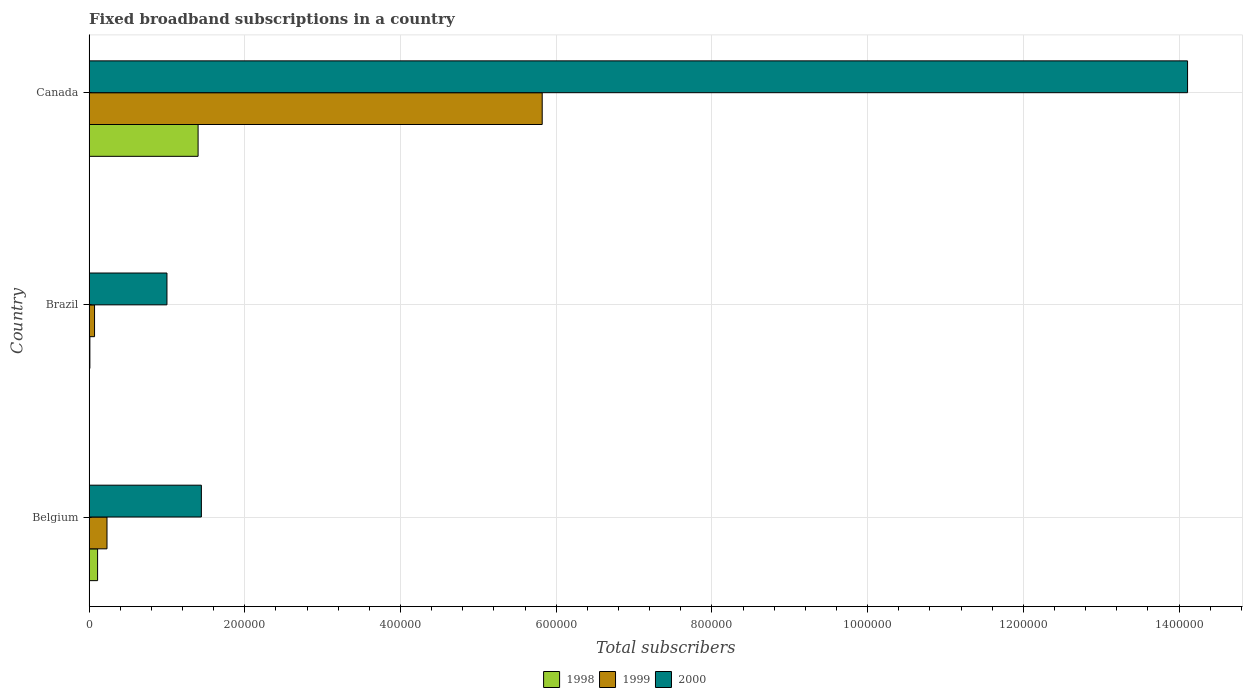How many different coloured bars are there?
Provide a short and direct response. 3. How many groups of bars are there?
Make the answer very short. 3. Are the number of bars per tick equal to the number of legend labels?
Your response must be concise. Yes. How many bars are there on the 3rd tick from the top?
Your answer should be compact. 3. What is the label of the 1st group of bars from the top?
Offer a terse response. Canada. What is the number of broadband subscriptions in 1999 in Belgium?
Keep it short and to the point. 2.30e+04. Across all countries, what is the maximum number of broadband subscriptions in 1999?
Your response must be concise. 5.82e+05. In which country was the number of broadband subscriptions in 2000 minimum?
Provide a succinct answer. Brazil. What is the total number of broadband subscriptions in 2000 in the graph?
Offer a very short reply. 1.66e+06. What is the difference between the number of broadband subscriptions in 2000 in Belgium and that in Brazil?
Offer a very short reply. 4.42e+04. What is the difference between the number of broadband subscriptions in 1999 in Canada and the number of broadband subscriptions in 2000 in Brazil?
Ensure brevity in your answer.  4.82e+05. What is the average number of broadband subscriptions in 2000 per country?
Provide a succinct answer. 5.52e+05. What is the difference between the number of broadband subscriptions in 2000 and number of broadband subscriptions in 1998 in Canada?
Your response must be concise. 1.27e+06. In how many countries, is the number of broadband subscriptions in 1999 greater than 960000 ?
Give a very brief answer. 0. What is the ratio of the number of broadband subscriptions in 1999 in Brazil to that in Canada?
Your answer should be very brief. 0.01. Is the number of broadband subscriptions in 1998 in Belgium less than that in Brazil?
Offer a very short reply. No. Is the difference between the number of broadband subscriptions in 2000 in Brazil and Canada greater than the difference between the number of broadband subscriptions in 1998 in Brazil and Canada?
Make the answer very short. No. What is the difference between the highest and the second highest number of broadband subscriptions in 1998?
Your response must be concise. 1.29e+05. What is the difference between the highest and the lowest number of broadband subscriptions in 1998?
Offer a very short reply. 1.39e+05. Is it the case that in every country, the sum of the number of broadband subscriptions in 1999 and number of broadband subscriptions in 1998 is greater than the number of broadband subscriptions in 2000?
Give a very brief answer. No. What is the difference between two consecutive major ticks on the X-axis?
Give a very brief answer. 2.00e+05. Does the graph contain any zero values?
Ensure brevity in your answer.  No. Does the graph contain grids?
Your answer should be very brief. Yes. Where does the legend appear in the graph?
Keep it short and to the point. Bottom center. How are the legend labels stacked?
Provide a succinct answer. Horizontal. What is the title of the graph?
Provide a succinct answer. Fixed broadband subscriptions in a country. What is the label or title of the X-axis?
Your answer should be very brief. Total subscribers. What is the label or title of the Y-axis?
Ensure brevity in your answer.  Country. What is the Total subscribers in 1998 in Belgium?
Give a very brief answer. 1.09e+04. What is the Total subscribers of 1999 in Belgium?
Your answer should be compact. 2.30e+04. What is the Total subscribers of 2000 in Belgium?
Provide a succinct answer. 1.44e+05. What is the Total subscribers of 1998 in Brazil?
Provide a succinct answer. 1000. What is the Total subscribers in 1999 in Brazil?
Give a very brief answer. 7000. What is the Total subscribers of 2000 in Brazil?
Your answer should be very brief. 1.00e+05. What is the Total subscribers of 1998 in Canada?
Offer a terse response. 1.40e+05. What is the Total subscribers of 1999 in Canada?
Offer a very short reply. 5.82e+05. What is the Total subscribers in 2000 in Canada?
Ensure brevity in your answer.  1.41e+06. Across all countries, what is the maximum Total subscribers in 1999?
Ensure brevity in your answer.  5.82e+05. Across all countries, what is the maximum Total subscribers of 2000?
Provide a succinct answer. 1.41e+06. Across all countries, what is the minimum Total subscribers of 1998?
Offer a terse response. 1000. Across all countries, what is the minimum Total subscribers of 1999?
Offer a terse response. 7000. What is the total Total subscribers of 1998 in the graph?
Your response must be concise. 1.52e+05. What is the total Total subscribers in 1999 in the graph?
Your answer should be very brief. 6.12e+05. What is the total Total subscribers of 2000 in the graph?
Make the answer very short. 1.66e+06. What is the difference between the Total subscribers of 1998 in Belgium and that in Brazil?
Provide a short and direct response. 9924. What is the difference between the Total subscribers in 1999 in Belgium and that in Brazil?
Keep it short and to the point. 1.60e+04. What is the difference between the Total subscribers of 2000 in Belgium and that in Brazil?
Offer a very short reply. 4.42e+04. What is the difference between the Total subscribers in 1998 in Belgium and that in Canada?
Provide a succinct answer. -1.29e+05. What is the difference between the Total subscribers in 1999 in Belgium and that in Canada?
Provide a short and direct response. -5.59e+05. What is the difference between the Total subscribers of 2000 in Belgium and that in Canada?
Provide a short and direct response. -1.27e+06. What is the difference between the Total subscribers in 1998 in Brazil and that in Canada?
Offer a very short reply. -1.39e+05. What is the difference between the Total subscribers in 1999 in Brazil and that in Canada?
Ensure brevity in your answer.  -5.75e+05. What is the difference between the Total subscribers in 2000 in Brazil and that in Canada?
Your answer should be compact. -1.31e+06. What is the difference between the Total subscribers of 1998 in Belgium and the Total subscribers of 1999 in Brazil?
Your answer should be very brief. 3924. What is the difference between the Total subscribers in 1998 in Belgium and the Total subscribers in 2000 in Brazil?
Give a very brief answer. -8.91e+04. What is the difference between the Total subscribers of 1999 in Belgium and the Total subscribers of 2000 in Brazil?
Offer a terse response. -7.70e+04. What is the difference between the Total subscribers in 1998 in Belgium and the Total subscribers in 1999 in Canada?
Your response must be concise. -5.71e+05. What is the difference between the Total subscribers in 1998 in Belgium and the Total subscribers in 2000 in Canada?
Provide a succinct answer. -1.40e+06. What is the difference between the Total subscribers of 1999 in Belgium and the Total subscribers of 2000 in Canada?
Make the answer very short. -1.39e+06. What is the difference between the Total subscribers of 1998 in Brazil and the Total subscribers of 1999 in Canada?
Your response must be concise. -5.81e+05. What is the difference between the Total subscribers of 1998 in Brazil and the Total subscribers of 2000 in Canada?
Your response must be concise. -1.41e+06. What is the difference between the Total subscribers of 1999 in Brazil and the Total subscribers of 2000 in Canada?
Give a very brief answer. -1.40e+06. What is the average Total subscribers of 1998 per country?
Give a very brief answer. 5.06e+04. What is the average Total subscribers of 1999 per country?
Make the answer very short. 2.04e+05. What is the average Total subscribers of 2000 per country?
Keep it short and to the point. 5.52e+05. What is the difference between the Total subscribers in 1998 and Total subscribers in 1999 in Belgium?
Give a very brief answer. -1.21e+04. What is the difference between the Total subscribers in 1998 and Total subscribers in 2000 in Belgium?
Give a very brief answer. -1.33e+05. What is the difference between the Total subscribers in 1999 and Total subscribers in 2000 in Belgium?
Give a very brief answer. -1.21e+05. What is the difference between the Total subscribers in 1998 and Total subscribers in 1999 in Brazil?
Provide a short and direct response. -6000. What is the difference between the Total subscribers in 1998 and Total subscribers in 2000 in Brazil?
Offer a terse response. -9.90e+04. What is the difference between the Total subscribers of 1999 and Total subscribers of 2000 in Brazil?
Your answer should be compact. -9.30e+04. What is the difference between the Total subscribers of 1998 and Total subscribers of 1999 in Canada?
Offer a very short reply. -4.42e+05. What is the difference between the Total subscribers in 1998 and Total subscribers in 2000 in Canada?
Your response must be concise. -1.27e+06. What is the difference between the Total subscribers of 1999 and Total subscribers of 2000 in Canada?
Provide a succinct answer. -8.29e+05. What is the ratio of the Total subscribers in 1998 in Belgium to that in Brazil?
Your response must be concise. 10.92. What is the ratio of the Total subscribers of 1999 in Belgium to that in Brazil?
Keep it short and to the point. 3.29. What is the ratio of the Total subscribers of 2000 in Belgium to that in Brazil?
Make the answer very short. 1.44. What is the ratio of the Total subscribers in 1998 in Belgium to that in Canada?
Provide a succinct answer. 0.08. What is the ratio of the Total subscribers of 1999 in Belgium to that in Canada?
Give a very brief answer. 0.04. What is the ratio of the Total subscribers of 2000 in Belgium to that in Canada?
Provide a succinct answer. 0.1. What is the ratio of the Total subscribers of 1998 in Brazil to that in Canada?
Ensure brevity in your answer.  0.01. What is the ratio of the Total subscribers in 1999 in Brazil to that in Canada?
Provide a succinct answer. 0.01. What is the ratio of the Total subscribers in 2000 in Brazil to that in Canada?
Provide a succinct answer. 0.07. What is the difference between the highest and the second highest Total subscribers of 1998?
Provide a succinct answer. 1.29e+05. What is the difference between the highest and the second highest Total subscribers of 1999?
Make the answer very short. 5.59e+05. What is the difference between the highest and the second highest Total subscribers in 2000?
Provide a succinct answer. 1.27e+06. What is the difference between the highest and the lowest Total subscribers in 1998?
Give a very brief answer. 1.39e+05. What is the difference between the highest and the lowest Total subscribers of 1999?
Your answer should be very brief. 5.75e+05. What is the difference between the highest and the lowest Total subscribers of 2000?
Provide a short and direct response. 1.31e+06. 